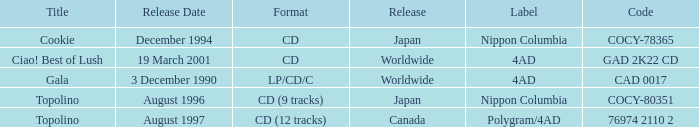What Label released an album in August 1996? Nippon Columbia. 